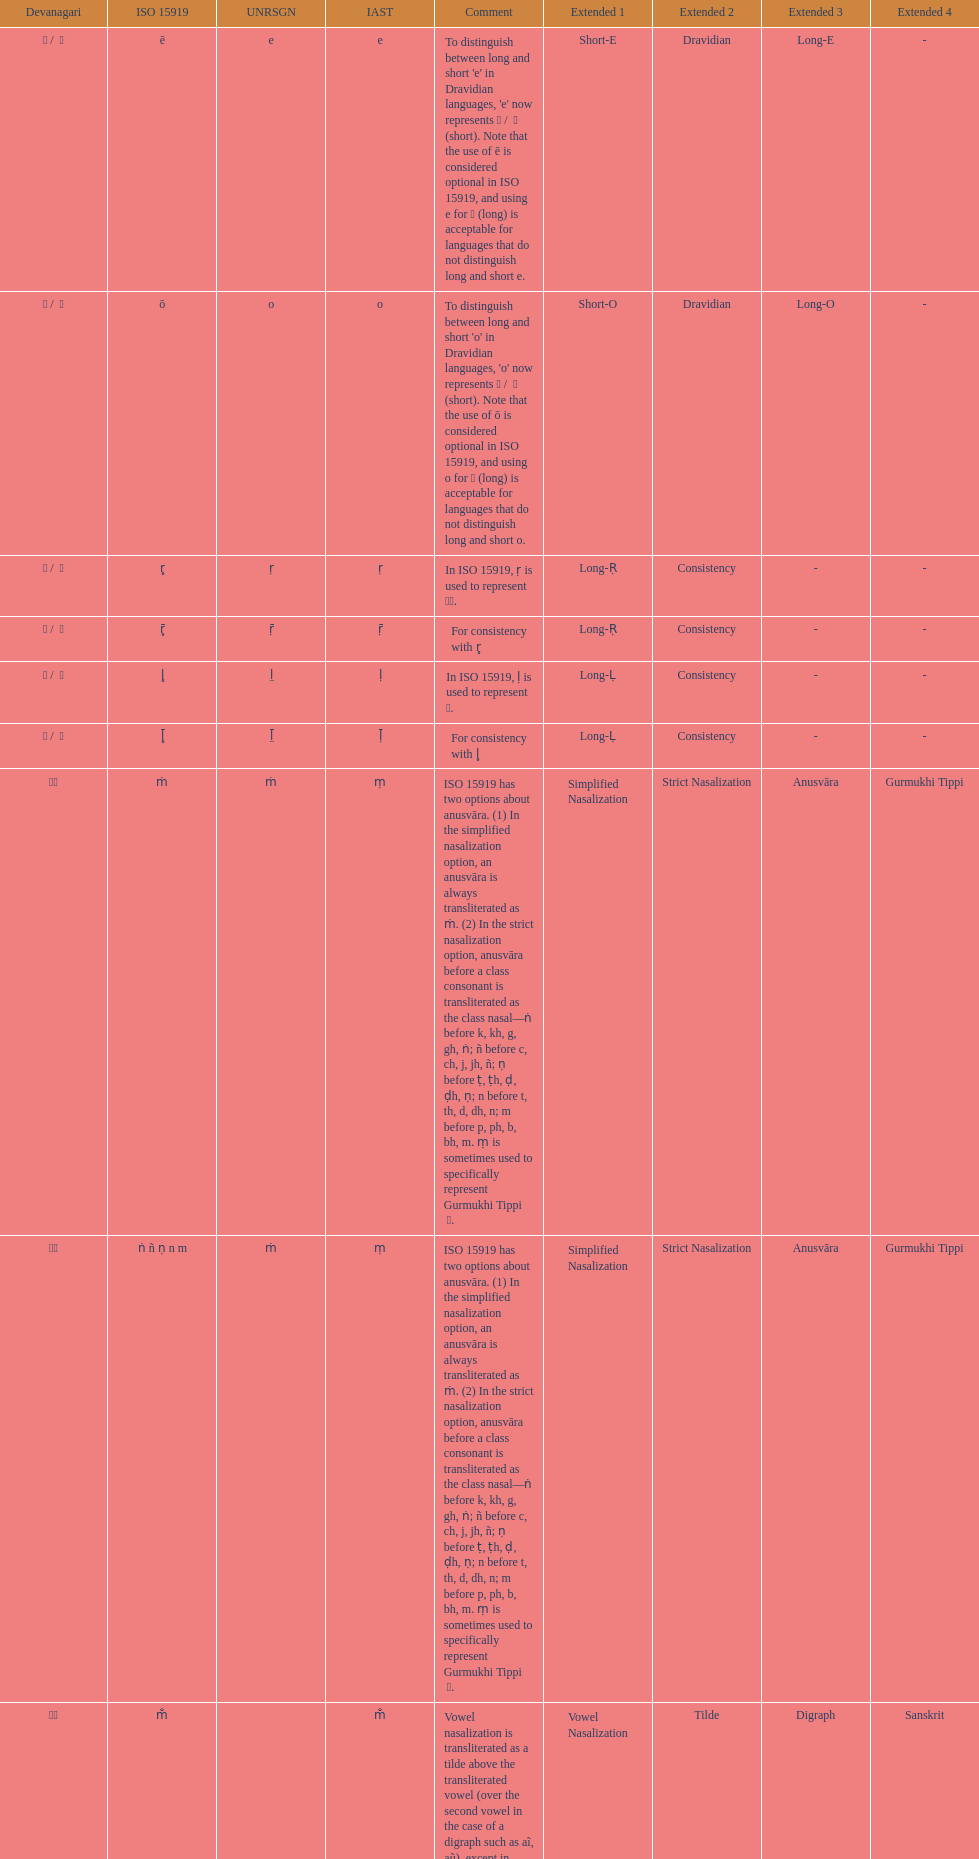How many total options are there about anusvara? 2. 